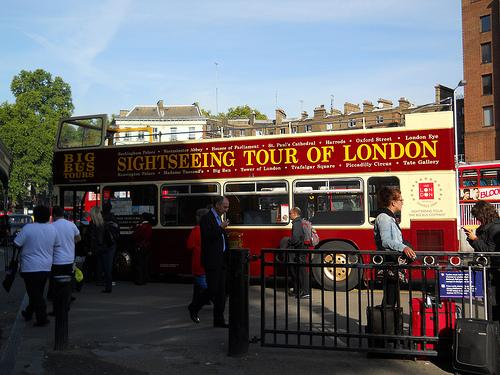Identify the key elements and their colors in this image. A red double-decker bus, black and red suitcases, blue sign with white writing, woman with long red hair, black gate, and black tire on a bus. Describe the location and atmosphere in the picture. A bustling street in London with a red double-decker tour bus, suitcases, and people interacting with various objects, giving a lively atmosphere. Write a brief description of the image highlighting the human figures and their characteristics. A woman with long red hair grasps an iron barricade, a man wears a yellow hat, another man has a backpack, and there's a woman with long blonde hair. Summarize the image by highlighting its most prominent features. A double-decker red tour bus in London has suitcases and bags on the ground, a man with a backpack, a woman with glasses, and various signs and details. List some of the objects present in the image and their attributes. Double-decker red bus, black gate, black and red suitcases, woman with long red hair, man with yellow hat, blue sign with white writing. Describe the bus in the image along with a few key details. A double-decker red tour bus in London has a window, yellow print, a rusted hubcap, vent on its side, and a tire. What is the most eye-catching object in the image, and what does it convey? The double-decker red bus is the most eye-catching object and conveys that the scene is in London, depicting a guided tour. What are some of the activities people in the image appear to be engaged in? A woman is grasping an iron barricade, a man with yellow hat is hanging from a belt loop, and another man is wearing a backpack. How would you describe the variety of objects in the image? A diverse array of objects such as buses, suitcases, signboards, building elements, and people with unique features and actions. 